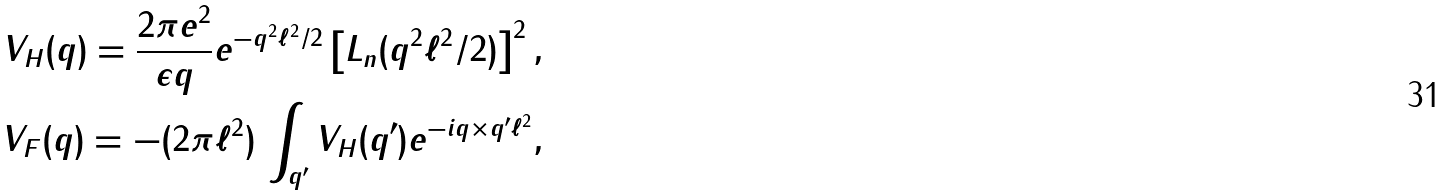<formula> <loc_0><loc_0><loc_500><loc_500>V _ { H } ( { q } ) = \frac { 2 \pi e ^ { 2 } } { \epsilon q } e ^ { - q ^ { 2 } \ell ^ { 2 } / 2 } \left [ L _ { n } ( q ^ { 2 } \ell ^ { 2 } / 2 ) \right ] ^ { 2 } , \\ V _ { F } ( { q } ) = - ( 2 \pi \ell ^ { 2 } ) \, \int _ { { q } ^ { \prime } } V _ { H } ( { q } ^ { \prime } ) e ^ { - i { q } \times { q } ^ { \prime } \ell ^ { 2 } } ,</formula> 